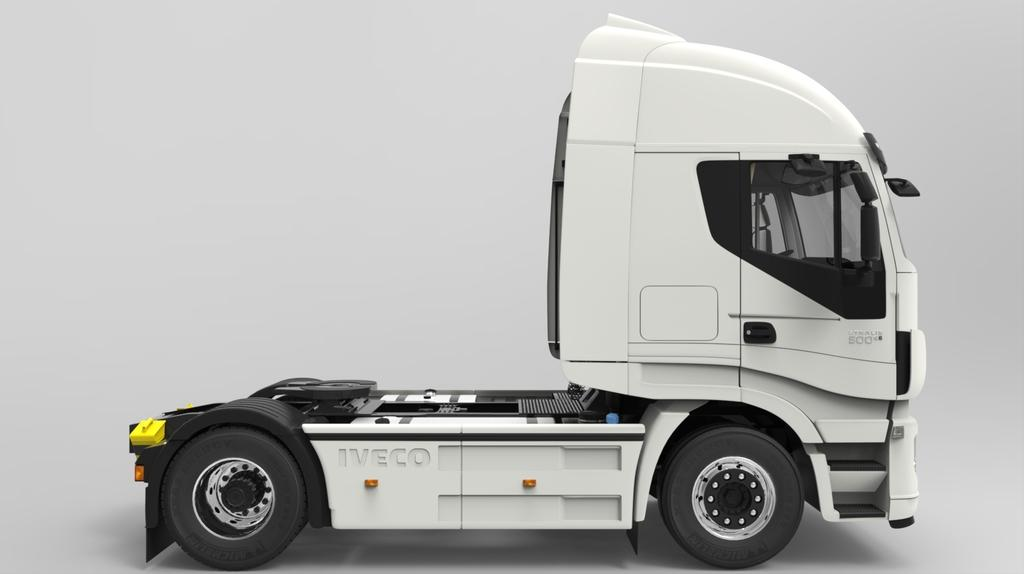What is the main subject of the image? There is a vehicle in the image. Can you describe the position of the vehicle? The vehicle is on a surface. What color is the background of the image? The background of the image is white. How many zebras can be seen through the window in the image? There is no window or zebras present in the image. 